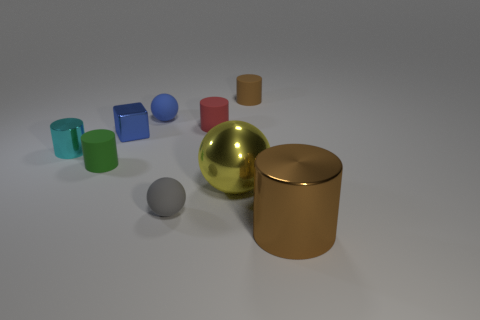What number of brown metallic objects have the same shape as the tiny blue metallic object?
Your response must be concise. 0. Is the number of tiny matte things that are left of the tiny gray thing the same as the number of small balls?
Your answer should be compact. Yes. What is the color of the object that is the same size as the brown shiny cylinder?
Your answer should be very brief. Yellow. Is there a tiny blue metal thing of the same shape as the small green thing?
Ensure brevity in your answer.  No. The brown cylinder left of the brown object that is to the right of the cylinder behind the small blue matte thing is made of what material?
Make the answer very short. Rubber. How many other objects are the same size as the green rubber object?
Offer a terse response. 6. What is the color of the small metal block?
Give a very brief answer. Blue. What number of shiny things are green cylinders or tiny purple spheres?
Provide a succinct answer. 0. There is a shiny cylinder behind the big shiny thing behind the shiny cylinder that is on the right side of the small cyan cylinder; what is its size?
Make the answer very short. Small. What size is the metallic thing that is both to the right of the cyan cylinder and behind the green cylinder?
Keep it short and to the point. Small. 